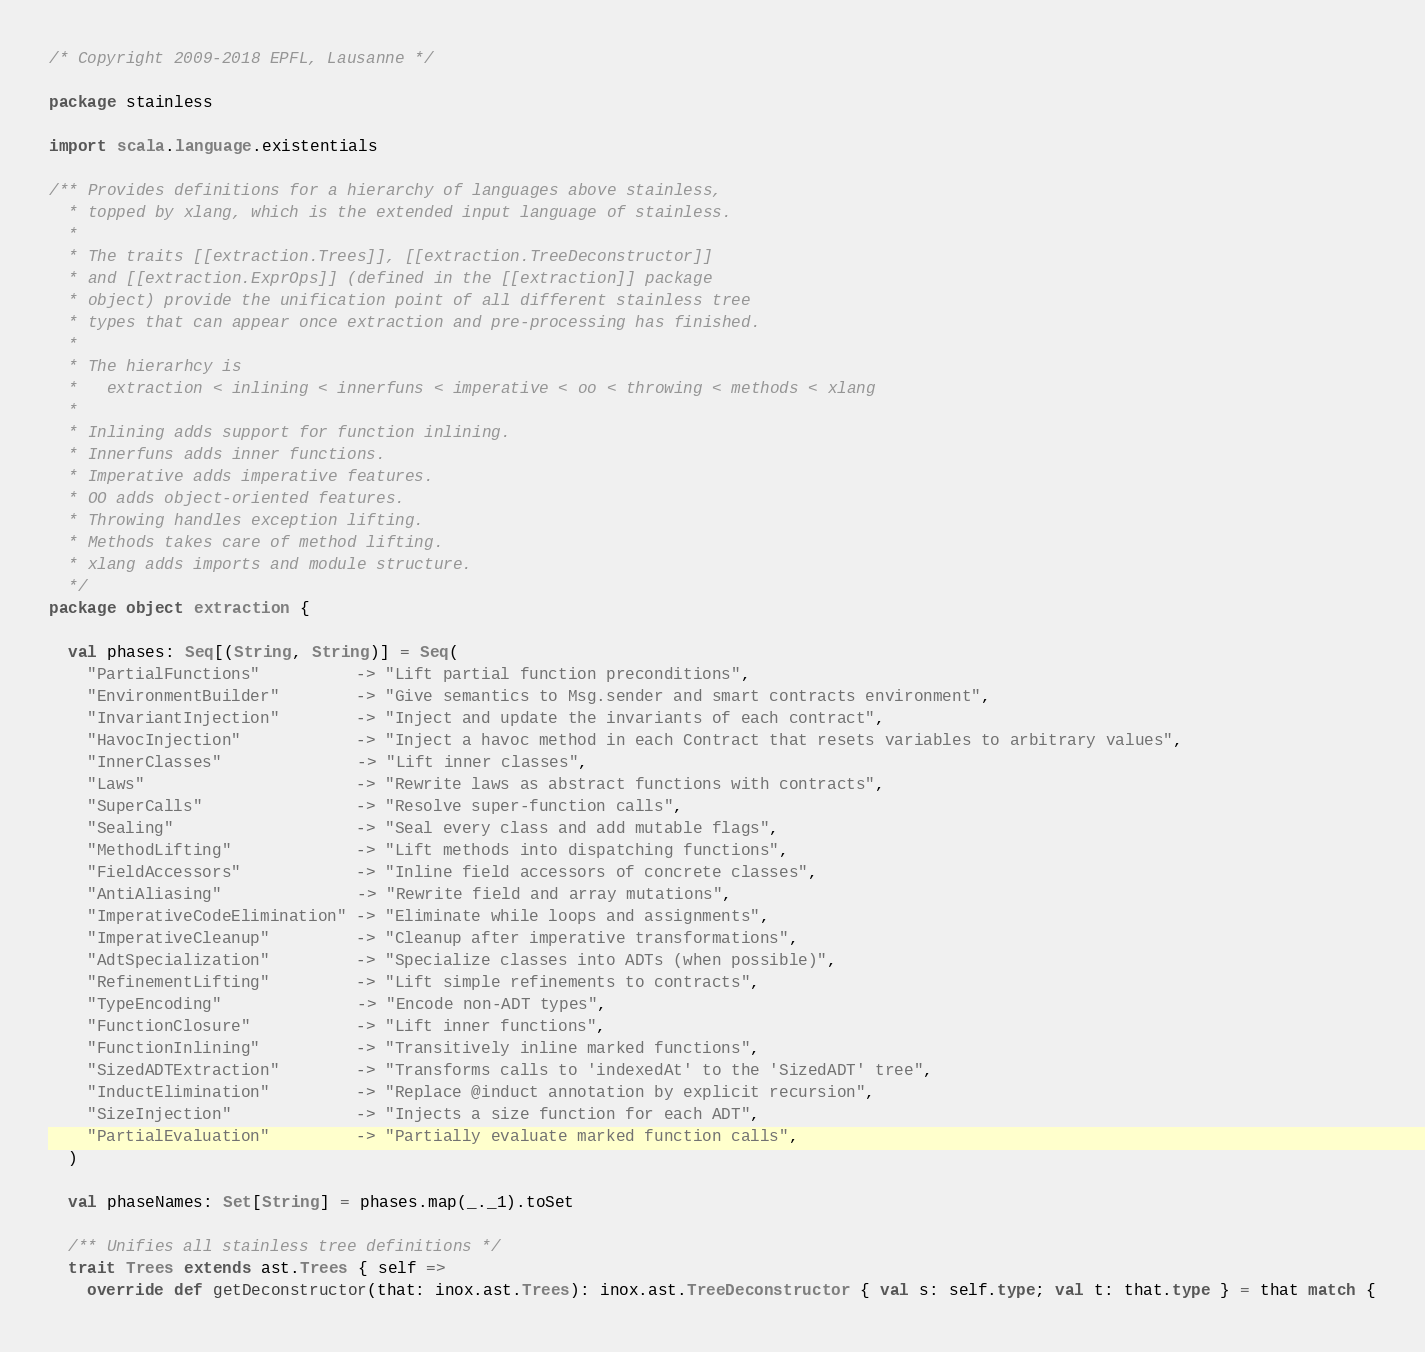<code> <loc_0><loc_0><loc_500><loc_500><_Scala_>/* Copyright 2009-2018 EPFL, Lausanne */

package stainless

import scala.language.existentials

/** Provides definitions for a hierarchy of languages above stainless,
  * topped by xlang, which is the extended input language of stainless.
  *
  * The traits [[extraction.Trees]], [[extraction.TreeDeconstructor]]
  * and [[extraction.ExprOps]] (defined in the [[extraction]] package
  * object) provide the unification point of all different stainless tree
  * types that can appear once extraction and pre-processing has finished.
  *
  * The hierarhcy is
  *   extraction < inlining < innerfuns < imperative < oo < throwing < methods < xlang
  *
  * Inlining adds support for function inlining.
  * Innerfuns adds inner functions.
  * Imperative adds imperative features.
  * OO adds object-oriented features.
  * Throwing handles exception lifting.
  * Methods takes care of method lifting.
  * xlang adds imports and module structure.
  */
package object extraction {

  val phases: Seq[(String, String)] = Seq(
    "PartialFunctions"          -> "Lift partial function preconditions",
    "EnvironmentBuilder"        -> "Give semantics to Msg.sender and smart contracts environment",
    "InvariantInjection"        -> "Inject and update the invariants of each contract",
    "HavocInjection"            -> "Inject a havoc method in each Contract that resets variables to arbitrary values",
    "InnerClasses"              -> "Lift inner classes",
    "Laws"                      -> "Rewrite laws as abstract functions with contracts",
    "SuperCalls"                -> "Resolve super-function calls",
    "Sealing"                   -> "Seal every class and add mutable flags",
    "MethodLifting"             -> "Lift methods into dispatching functions",
    "FieldAccessors"            -> "Inline field accessors of concrete classes",
    "AntiAliasing"              -> "Rewrite field and array mutations",
    "ImperativeCodeElimination" -> "Eliminate while loops and assignments",
    "ImperativeCleanup"         -> "Cleanup after imperative transformations",
    "AdtSpecialization"         -> "Specialize classes into ADTs (when possible)",
    "RefinementLifting"         -> "Lift simple refinements to contracts",
    "TypeEncoding"              -> "Encode non-ADT types",
    "FunctionClosure"           -> "Lift inner functions",
    "FunctionInlining"          -> "Transitively inline marked functions",
    "SizedADTExtraction"        -> "Transforms calls to 'indexedAt' to the 'SizedADT' tree",
    "InductElimination"         -> "Replace @induct annotation by explicit recursion",
    "SizeInjection"             -> "Injects a size function for each ADT",
    "PartialEvaluation"         -> "Partially evaluate marked function calls",
  )

  val phaseNames: Set[String] = phases.map(_._1).toSet

  /** Unifies all stainless tree definitions */
  trait Trees extends ast.Trees { self =>
    override def getDeconstructor(that: inox.ast.Trees): inox.ast.TreeDeconstructor { val s: self.type; val t: that.type } = that match {</code> 